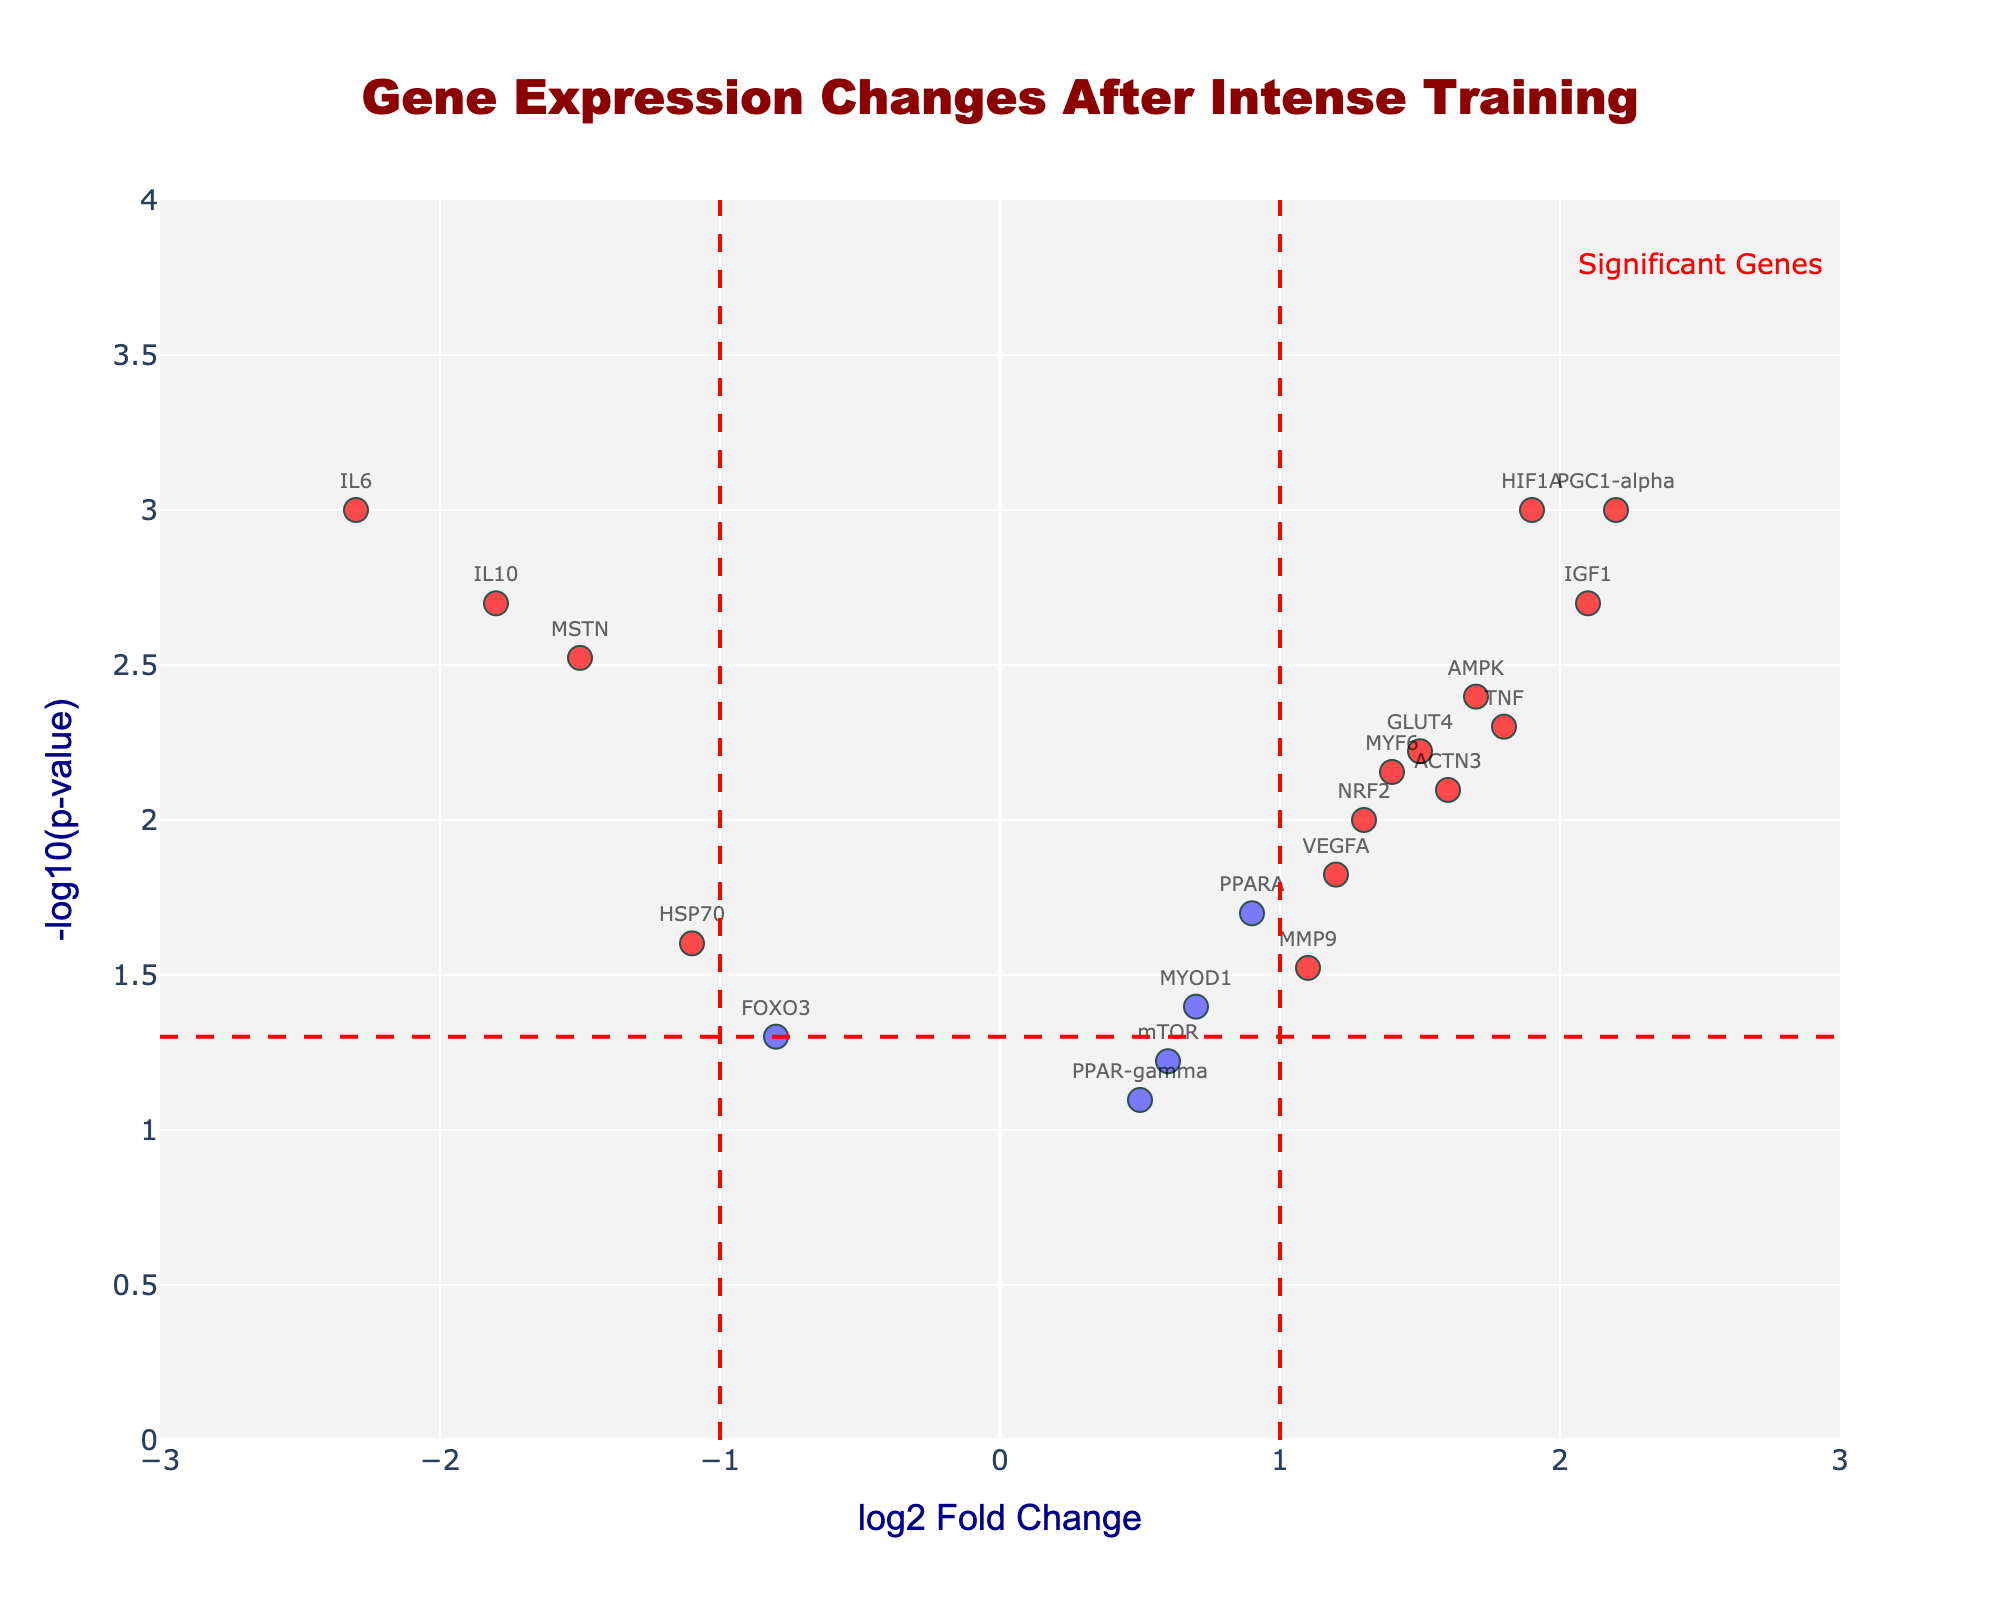What is the gene with the largest positive log2 fold change? The gene with the largest positive log2 fold change is PGC1-alpha, as it has a log2 fold change of 2.2.
Answer: PGC1-alpha How many genes have a log2 fold change greater than 1 and a p-value less than 0.005? The genes that satisfy both conditions (log2 fold change > 1 and p-value < 0.005) are TNF, IGF1, HIF1A, AMPK, and PGC1-alpha. Count them to get the total.
Answer: 5 Which gene has the lowest p-value? Look for the gene with the highest -log10(p-value) value. The gene with the highest -log10(p-value) is IL6, which corresponds to the lowest p-value.
Answer: IL6 Are there any genes with negative log2 fold change that are considered significant? Genes are considered significant if they have a p-value less than 0.05 and an absolute log2 fold change greater than 1. The negative log2 fold change genes that are significant are IL6, MSTN, and IL10.
Answer: Yes What gene has a log2 fold change of approximately 1.5 and is considered significant? The gene with a log2 fold change of approximately 1.5 and a p-value less than 0.05 is GLUT4.
Answer: GLUT4 Between the genes NRF2 and MYOD1, which has a lower p-value? Compare the -log10(p-value) values for NRF2 and MYOD1. NRF2 has a -log10(p-value) of -1.3/10 = 0.1 and MYOD1 has -1.4/20 = 0.07. Since 0.1 > 0.07, NRF2 has a lower p-value.
Answer: NRF2 Which gene shows a significant positive change in expression and is also associated with muscle differentiation? From the known gene functions, MYF6 is associated with muscle differentiation and shows a significant positive change (log2 fold change > 1 and p-value < 0.05).
Answer: MYF6 How many genes fall within the non-significant range (p-value ≥ 0.05)? Count the genes with a p-value equal to or greater than 0.05. There are two such genes, FOXO3 and mTOR.
Answer: 2 